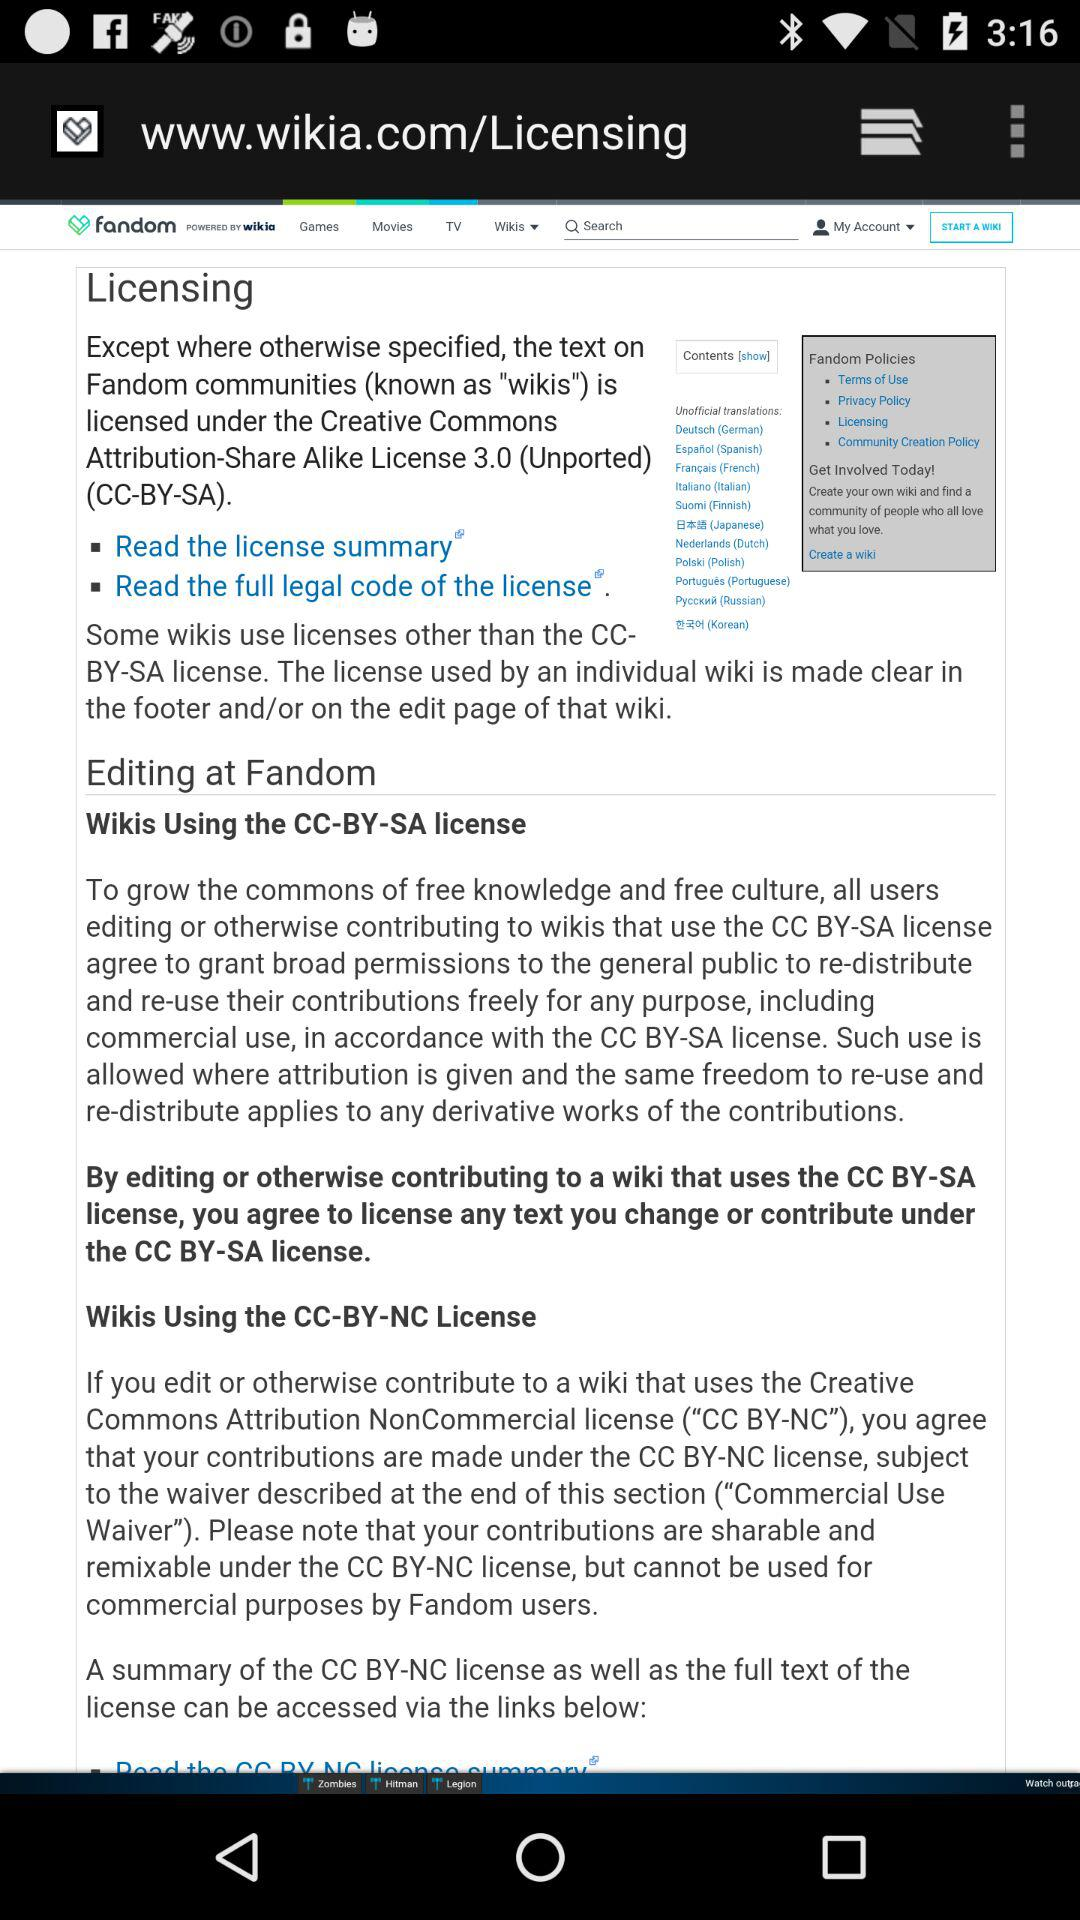How many licenses are mentioned on this page?
Answer the question using a single word or phrase. 2 